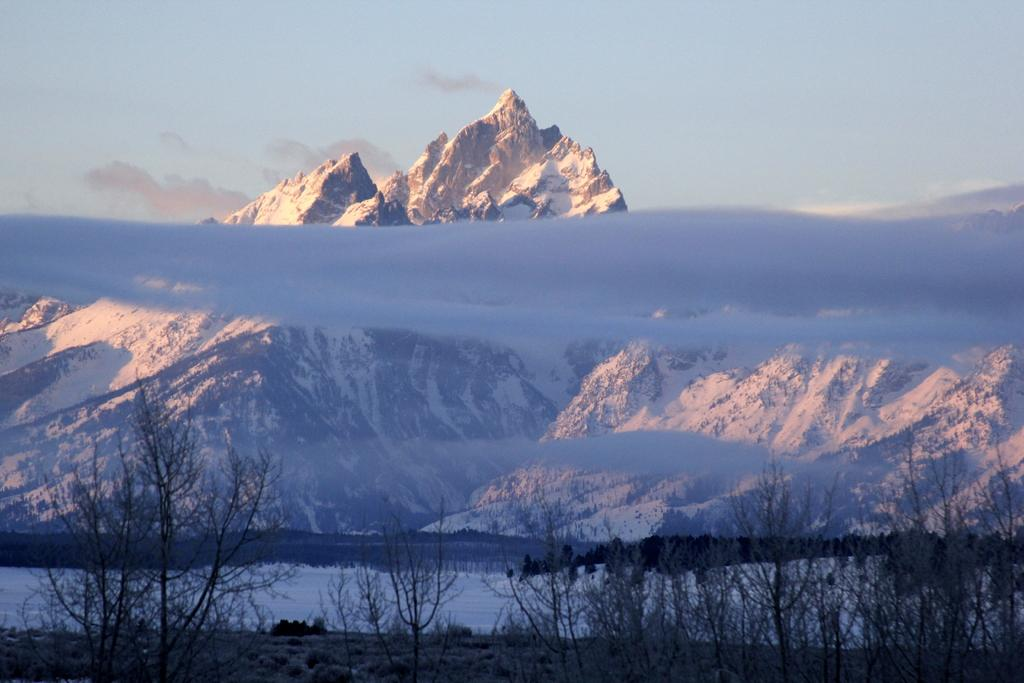What type of geographical feature is present in the image? There are mountains in the image. What is the condition of the mountains? The mountains have snow. What type of vegetation can be seen near the mountains? There are trees at the downside of the mountains. Can you see any jellyfish swimming in the snow on the mountains? There are no jellyfish present in the image; it features mountains with snow and trees. 